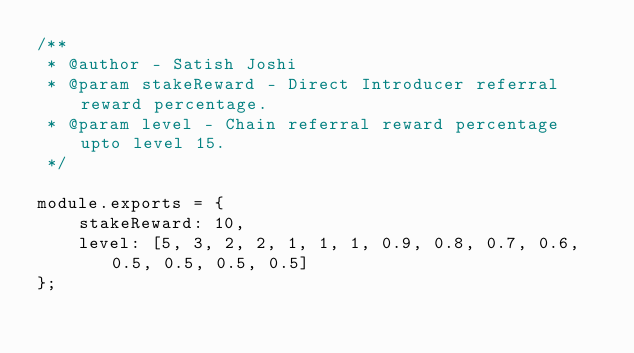Convert code to text. <code><loc_0><loc_0><loc_500><loc_500><_JavaScript_>/**
 * @author - Satish Joshi
 * @param stakeReward - Direct Introducer referral reward percentage.
 * @param level - Chain referral reward percentage upto level 15.
 */

module.exports = {
    stakeReward: 10,
    level: [5, 3, 2, 2, 1, 1, 1, 0.9, 0.8, 0.7, 0.6, 0.5, 0.5, 0.5, 0.5]
};
</code> 